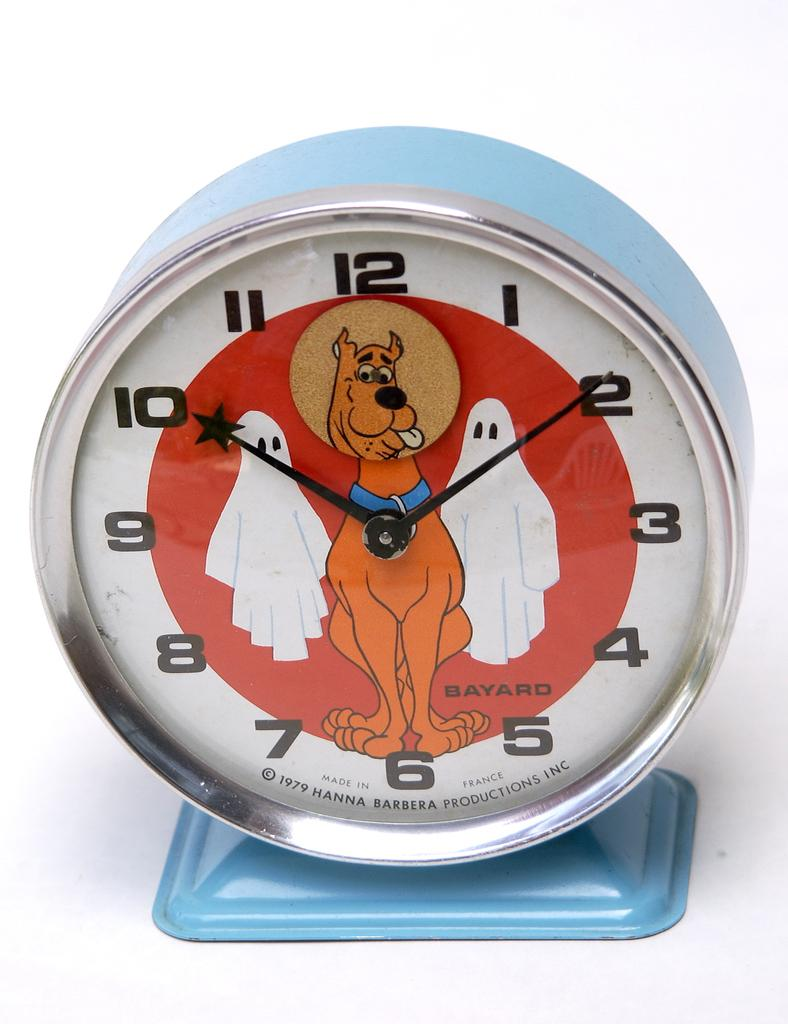<image>
Describe the image concisely. A 1979 clock from Hanna Barbera features Scooby Doo and some ghosts. 